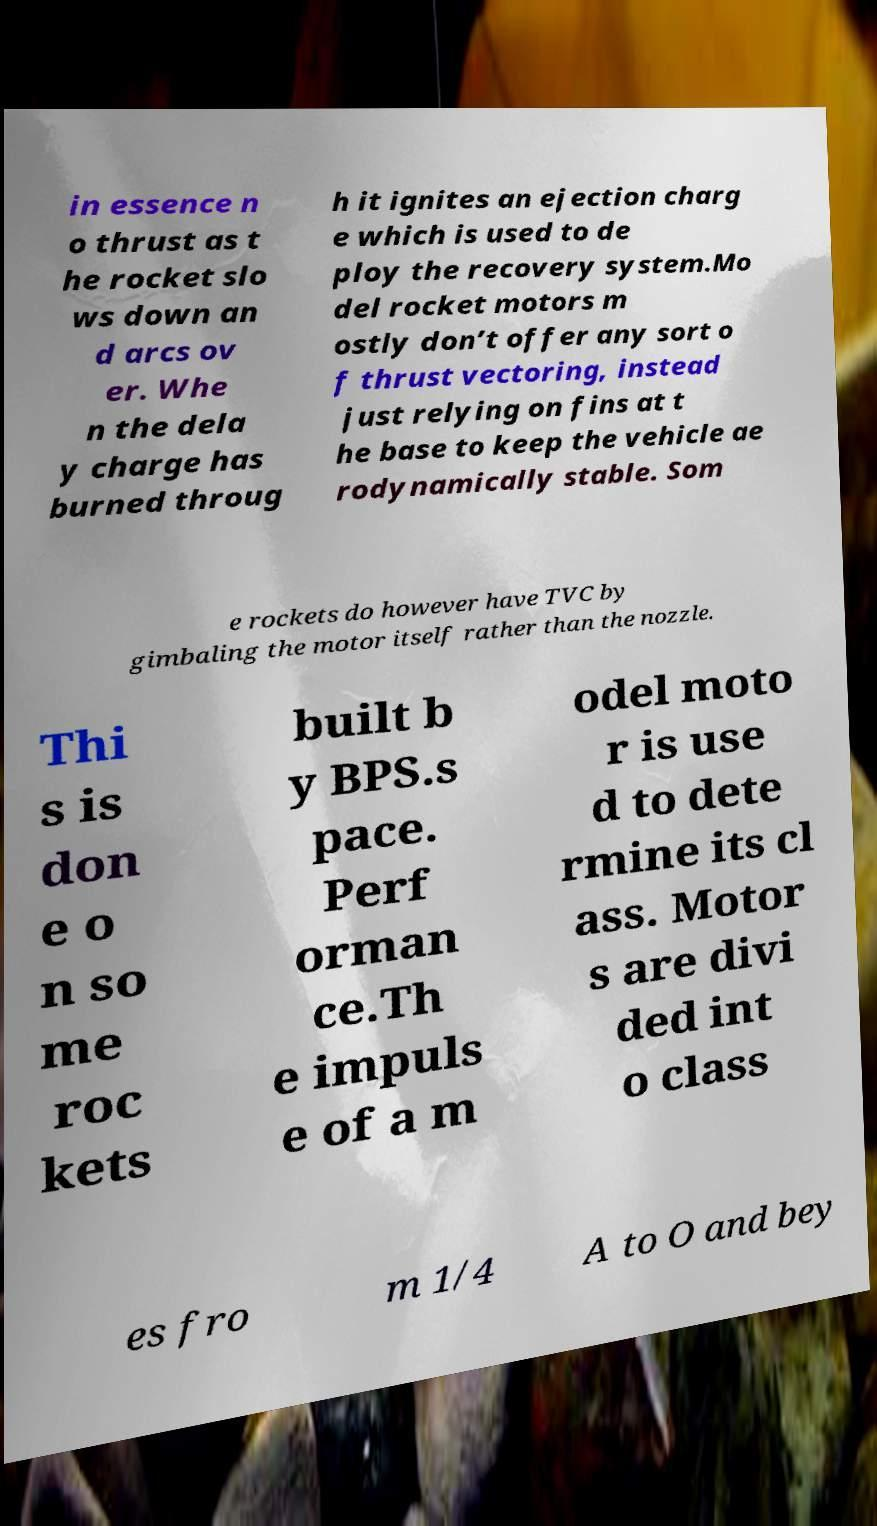Could you assist in decoding the text presented in this image and type it out clearly? in essence n o thrust as t he rocket slo ws down an d arcs ov er. Whe n the dela y charge has burned throug h it ignites an ejection charg e which is used to de ploy the recovery system.Mo del rocket motors m ostly don’t offer any sort o f thrust vectoring, instead just relying on fins at t he base to keep the vehicle ae rodynamically stable. Som e rockets do however have TVC by gimbaling the motor itself rather than the nozzle. Thi s is don e o n so me roc kets built b y BPS.s pace. Perf orman ce.Th e impuls e of a m odel moto r is use d to dete rmine its cl ass. Motor s are divi ded int o class es fro m 1/4 A to O and bey 